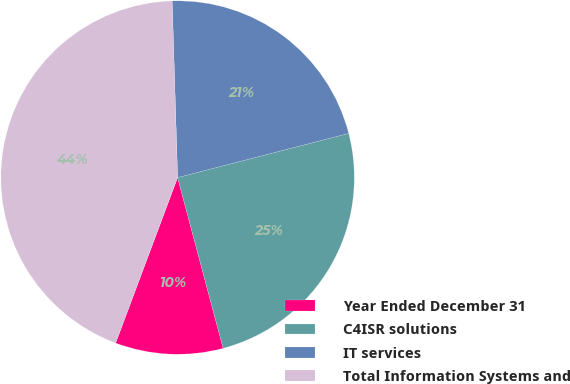<chart> <loc_0><loc_0><loc_500><loc_500><pie_chart><fcel>Year Ended December 31<fcel>C4ISR solutions<fcel>IT services<fcel>Total Information Systems and<nl><fcel>9.85%<fcel>24.87%<fcel>21.47%<fcel>43.81%<nl></chart> 